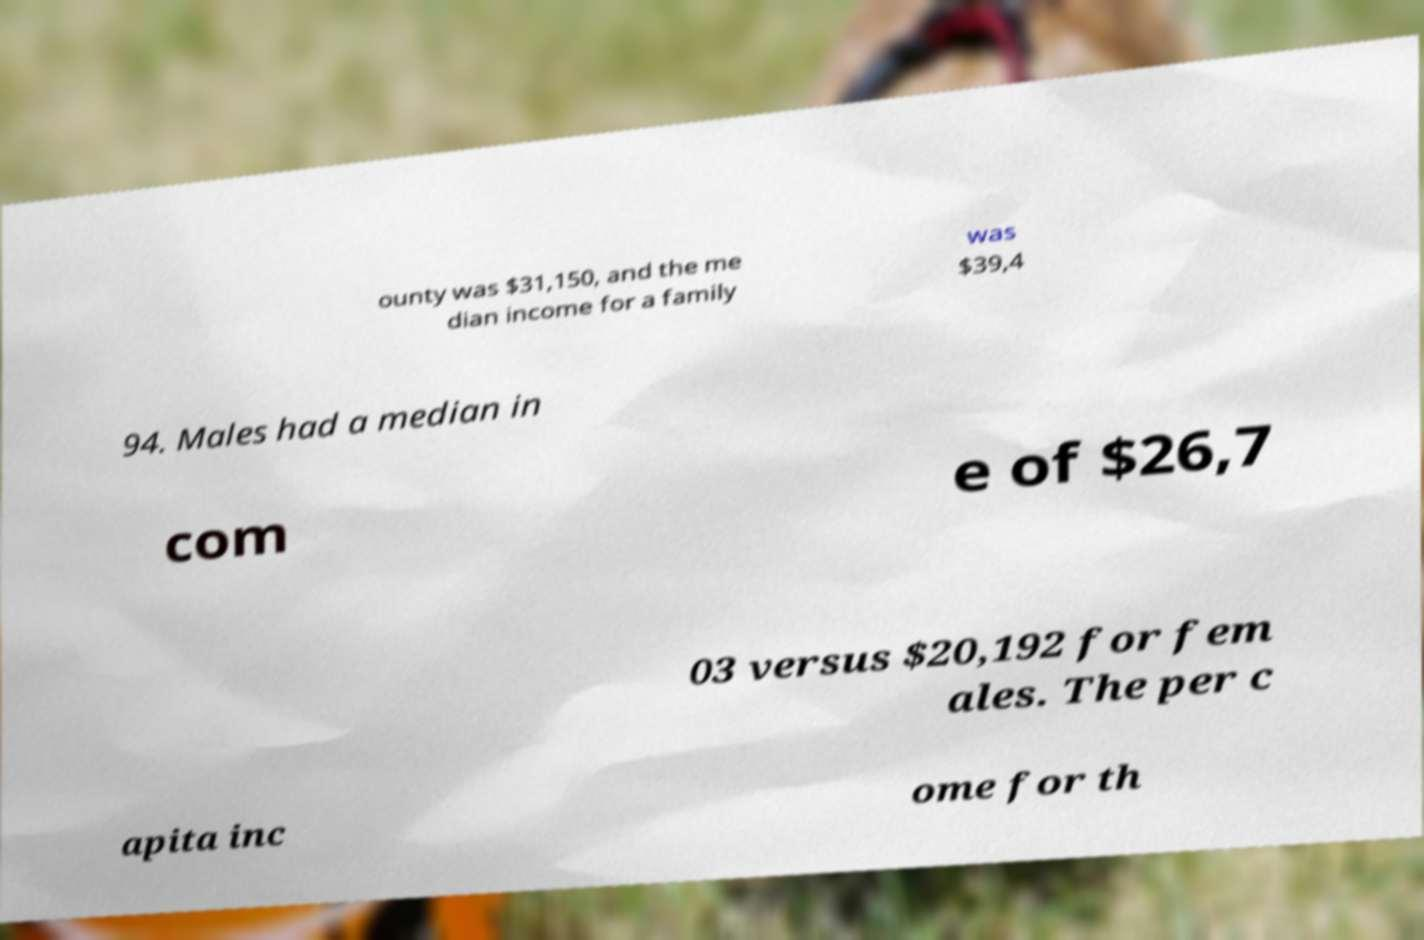Please read and relay the text visible in this image. What does it say? ounty was $31,150, and the me dian income for a family was $39,4 94. Males had a median in com e of $26,7 03 versus $20,192 for fem ales. The per c apita inc ome for th 